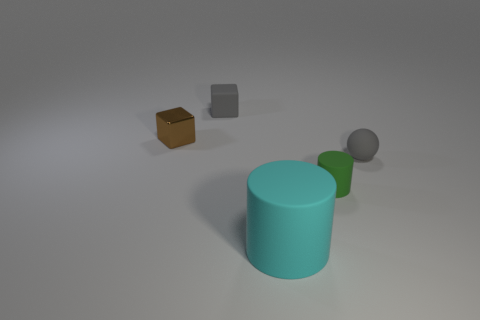How big is the object that is on the right side of the tiny brown block and behind the small gray sphere?
Your answer should be very brief. Small. There is a big thing that is to the right of the gray matte cube; what shape is it?
Your answer should be compact. Cylinder. Do the brown block and the small gray object that is right of the large cyan cylinder have the same material?
Ensure brevity in your answer.  No. Do the tiny brown thing and the large thing have the same shape?
Keep it short and to the point. No. There is another large object that is the same shape as the green object; what is its material?
Offer a very short reply. Rubber. The rubber object that is left of the small green thing and in front of the tiny gray matte ball is what color?
Ensure brevity in your answer.  Cyan. The large rubber object has what color?
Offer a terse response. Cyan. What is the material of the object that is the same color as the sphere?
Provide a succinct answer. Rubber. Are there any other brown matte objects of the same shape as the big thing?
Offer a very short reply. No. There is a gray rubber object in front of the small brown block; what is its size?
Keep it short and to the point. Small. 